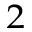<formula> <loc_0><loc_0><loc_500><loc_500>_ { 2 }</formula> 